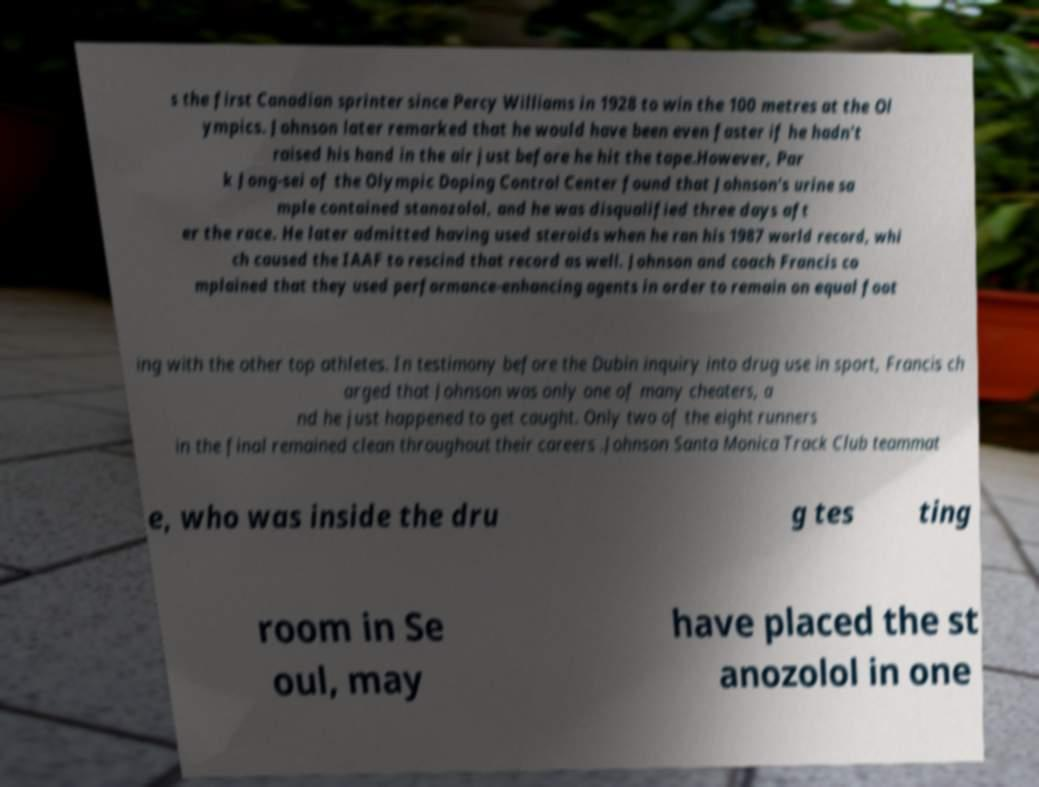What messages or text are displayed in this image? I need them in a readable, typed format. s the first Canadian sprinter since Percy Williams in 1928 to win the 100 metres at the Ol ympics. Johnson later remarked that he would have been even faster if he hadn't raised his hand in the air just before he hit the tape.However, Par k Jong-sei of the Olympic Doping Control Center found that Johnson's urine sa mple contained stanozolol, and he was disqualified three days aft er the race. He later admitted having used steroids when he ran his 1987 world record, whi ch caused the IAAF to rescind that record as well. Johnson and coach Francis co mplained that they used performance-enhancing agents in order to remain on equal foot ing with the other top athletes. In testimony before the Dubin inquiry into drug use in sport, Francis ch arged that Johnson was only one of many cheaters, a nd he just happened to get caught. Only two of the eight runners in the final remained clean throughout their careers .Johnson Santa Monica Track Club teammat e, who was inside the dru g tes ting room in Se oul, may have placed the st anozolol in one 